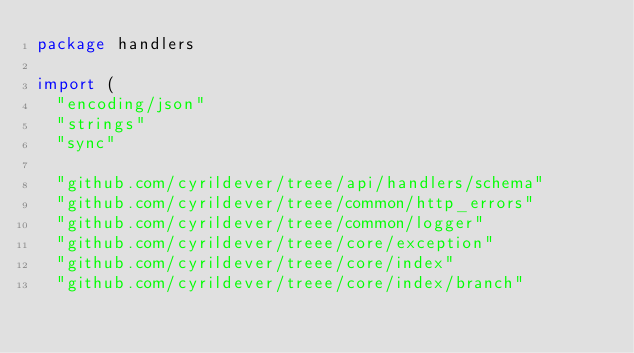Convert code to text. <code><loc_0><loc_0><loc_500><loc_500><_Go_>package handlers

import (
	"encoding/json"
	"strings"
	"sync"

	"github.com/cyrildever/treee/api/handlers/schema"
	"github.com/cyrildever/treee/common/http_errors"
	"github.com/cyrildever/treee/common/logger"
	"github.com/cyrildever/treee/core/exception"
	"github.com/cyrildever/treee/core/index"
	"github.com/cyrildever/treee/core/index/branch"</code> 